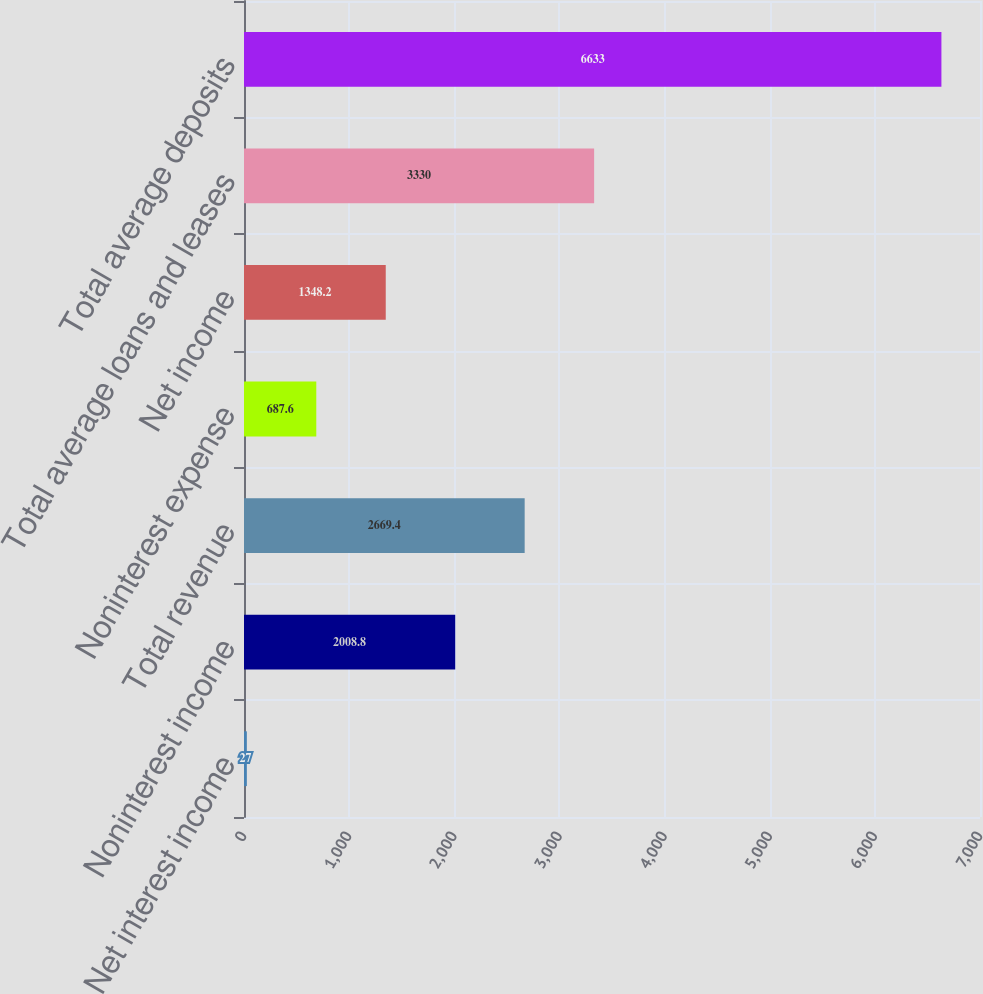Convert chart to OTSL. <chart><loc_0><loc_0><loc_500><loc_500><bar_chart><fcel>Net interest income<fcel>Noninterest income<fcel>Total revenue<fcel>Noninterest expense<fcel>Net income<fcel>Total average loans and leases<fcel>Total average deposits<nl><fcel>27<fcel>2008.8<fcel>2669.4<fcel>687.6<fcel>1348.2<fcel>3330<fcel>6633<nl></chart> 